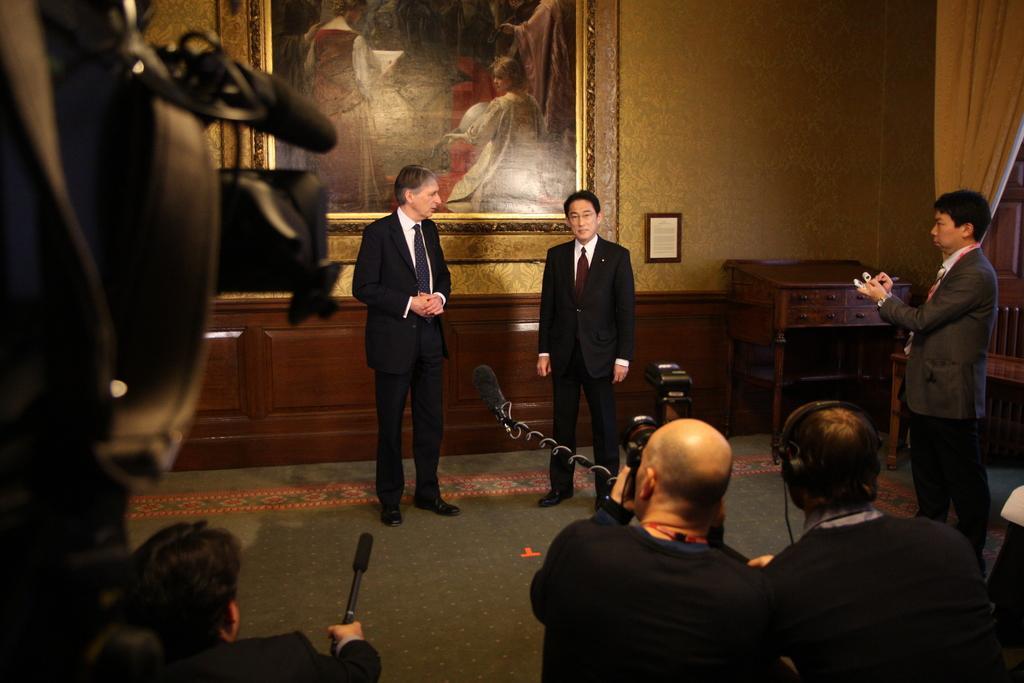Could you give a brief overview of what you see in this image? In this image in the front there are persons holding mic, camera. In the center there are persons standing. On the right side there is a man standing and writing. In the background there is a wall and on the wall there is a frame. On the right side there is a curtain and there is a table and on the left side there is a camera. 